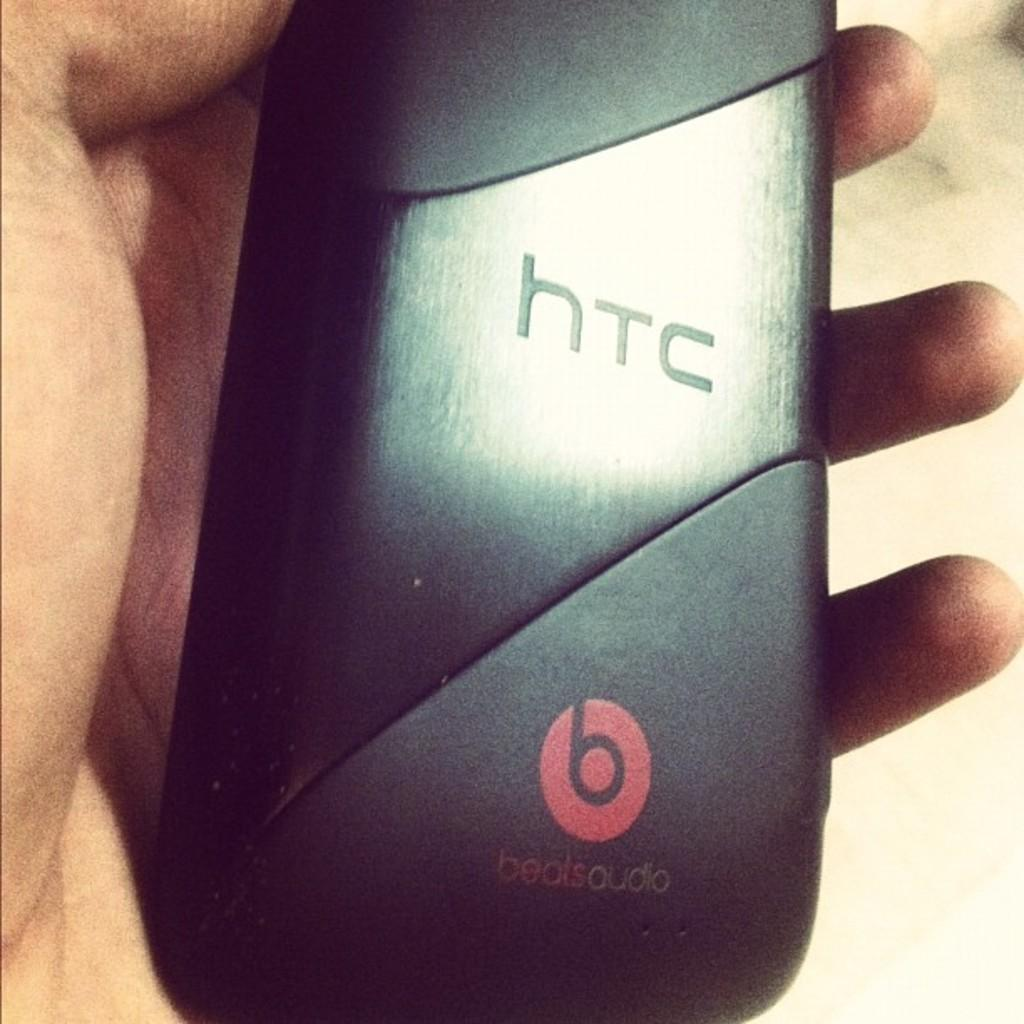<image>
Relay a brief, clear account of the picture shown. A hand holding a small black htc speaker 